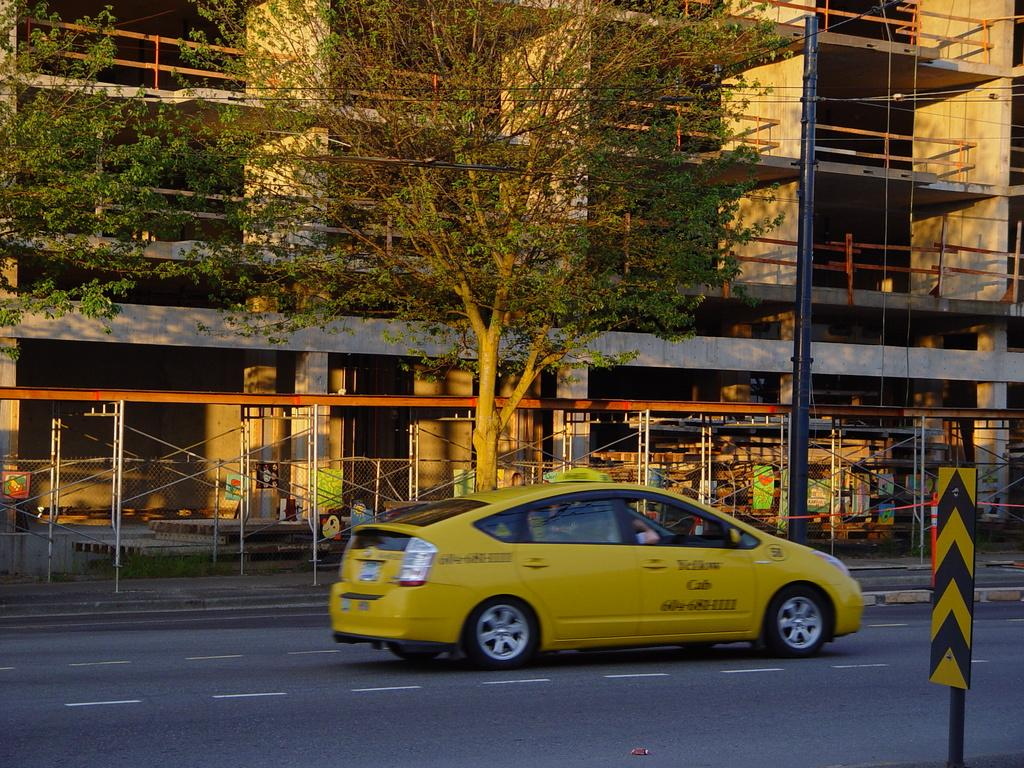Provide a one-sentence caption for the provided image. a Yellow Cab company cab on the street of a public place. 